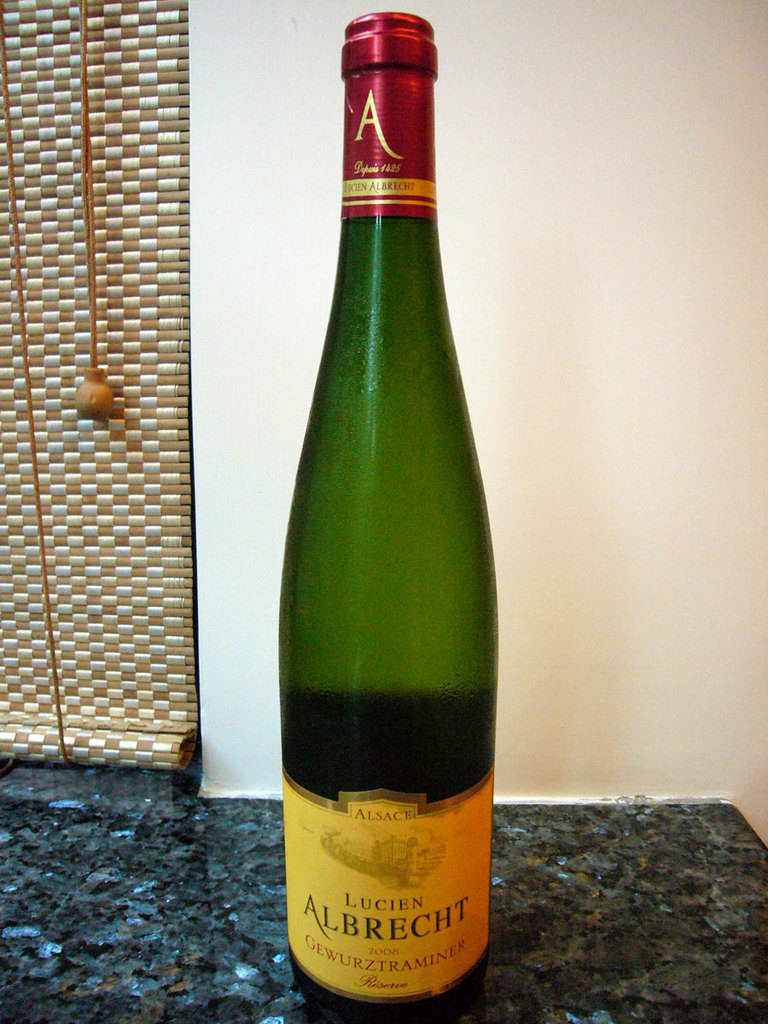Describe the visual elements that stand out in this wine bottle's presentation. The wine bottle features a sleek green glass body that elegantly showcases the bright golden-yellow label with bold, red accents. The Lucien Albrecht name and the year 2008 are prominently displayed, indicating its vintage nature and quality assurance. 